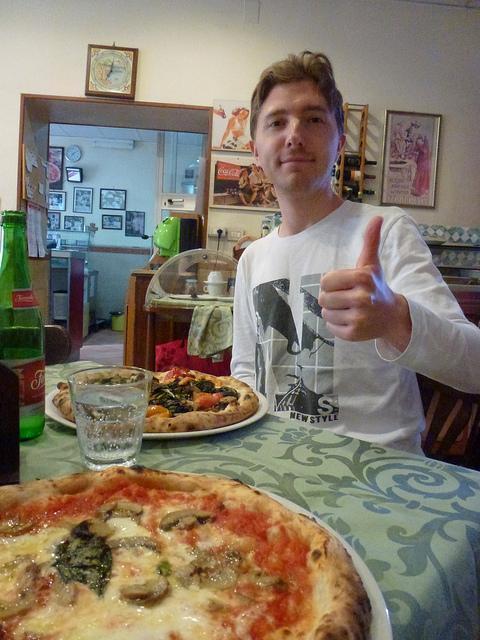How many pizzas are on the table?
Give a very brief answer. 2. How many people are dining?
Give a very brief answer. 1. How many hands are in the image?
Give a very brief answer. 1. How many pizzas are there?
Give a very brief answer. 2. 